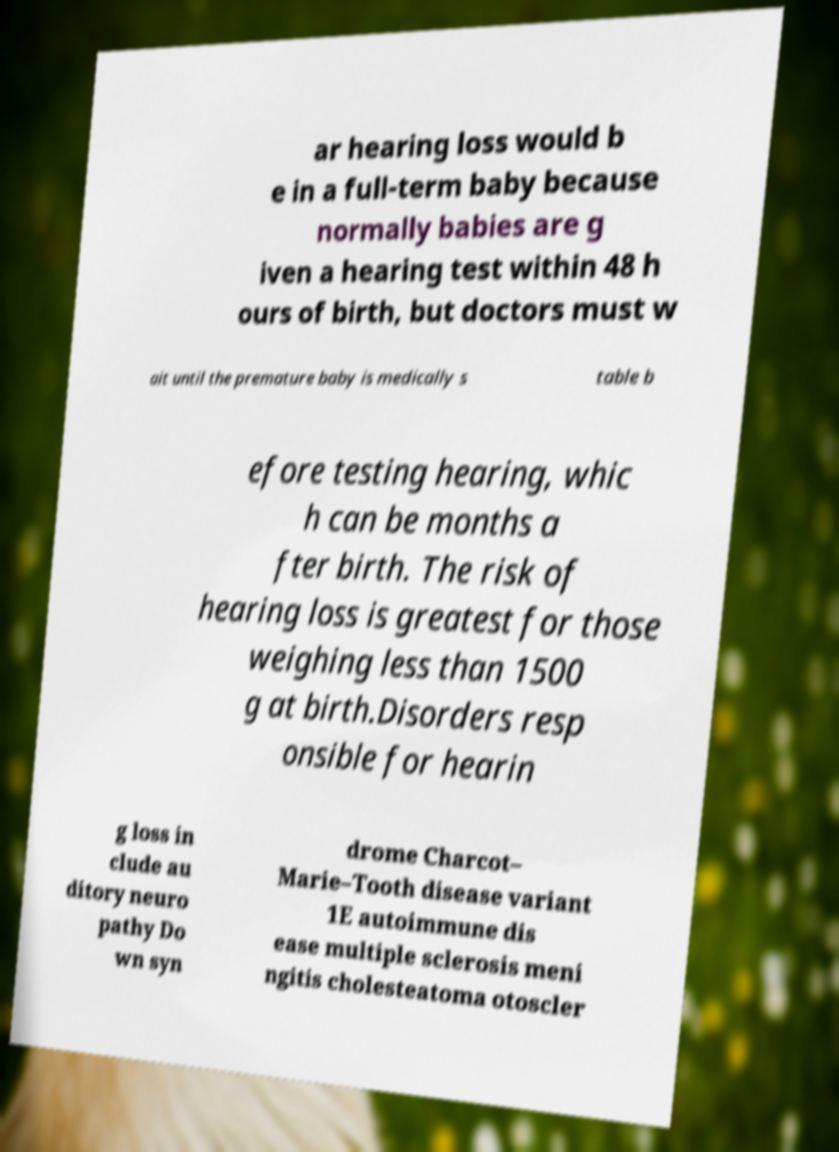For documentation purposes, I need the text within this image transcribed. Could you provide that? ar hearing loss would b e in a full-term baby because normally babies are g iven a hearing test within 48 h ours of birth, but doctors must w ait until the premature baby is medically s table b efore testing hearing, whic h can be months a fter birth. The risk of hearing loss is greatest for those weighing less than 1500 g at birth.Disorders resp onsible for hearin g loss in clude au ditory neuro pathy Do wn syn drome Charcot– Marie–Tooth disease variant 1E autoimmune dis ease multiple sclerosis meni ngitis cholesteatoma otoscler 